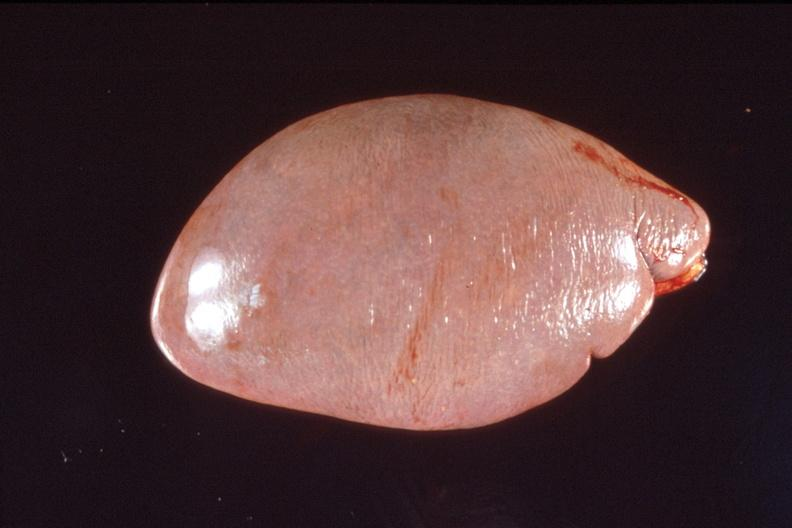does mucoepidermoid carcinoma show spleen, normal spleen?
Answer the question using a single word or phrase. No 